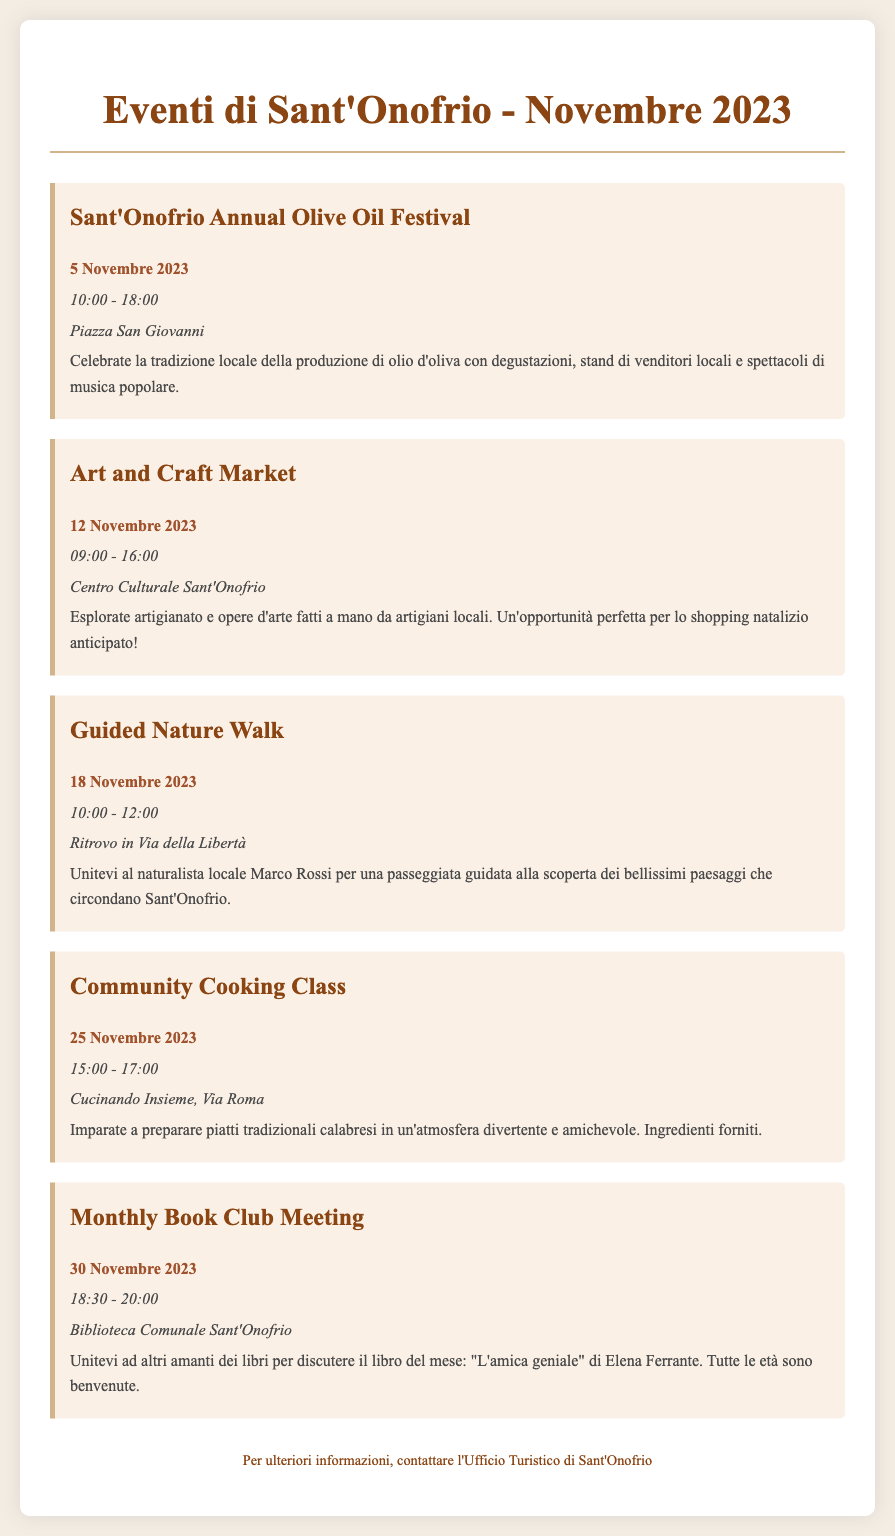What is the title of the first event? The first event listed is the Sant'Onofrio Annual Olive Oil Festival.
Answer: Sant'Onofrio Annual Olive Oil Festival When is the Community Cooking Class scheduled? The Community Cooking Class is scheduled for 25 Novembre 2023.
Answer: 25 Novembre 2023 What time does the Art and Craft Market start? The Art and Craft Market starts at 09:00.
Answer: 09:00 Where will the Guided Nature Walk take place? The Guided Nature Walk will meet in Via della Libertà.
Answer: Via della Libertà How many events are listed in total for November 2023? There are a total of 5 events listed for November 2023.
Answer: 5 What type of market is happening on 12 Novembre? The event is an Art and Craft Market.
Answer: Art and Craft Market What is the location for the Monthly Book Club Meeting? The Monthly Book Club Meeting will take place at Biblioteca Comunale Sant'Onofrio.
Answer: Biblioteca Comunale Sant'Onofrio Who is leading the Guided Nature Walk? The Guided Nature Walk is led by naturalista locale Marco Rossi.
Answer: Marco Rossi What book will be discussed in the Monthly Book Club Meeting? The book for discussion is "L'amica geniale" by Elena Ferrante.
Answer: "L'amica geniale" 